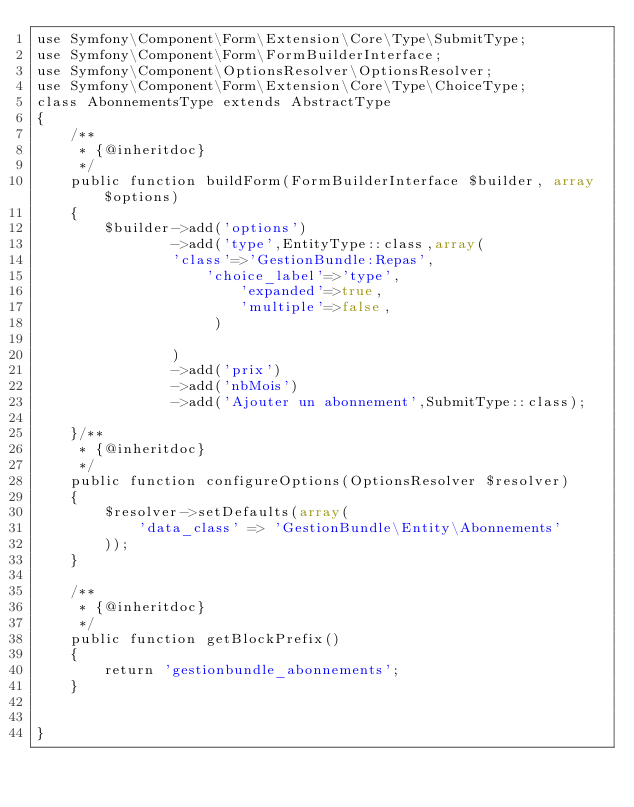<code> <loc_0><loc_0><loc_500><loc_500><_PHP_>use Symfony\Component\Form\Extension\Core\Type\SubmitType;
use Symfony\Component\Form\FormBuilderInterface;
use Symfony\Component\OptionsResolver\OptionsResolver;
use Symfony\Component\Form\Extension\Core\Type\ChoiceType;
class AbonnementsType extends AbstractType
{
    /**
     * {@inheritdoc}
     */
    public function buildForm(FormBuilderInterface $builder, array $options)
    {
        $builder->add('options')
                ->add('type',EntityType::class,array(
                'class'=>'GestionBundle:Repas',
                    'choice_label'=>'type',
                        'expanded'=>true,
                        'multiple'=>false,
                     )

                )
                ->add('prix')
                ->add('nbMois')
                ->add('Ajouter un abonnement',SubmitType::class);

    }/**
     * {@inheritdoc}
     */
    public function configureOptions(OptionsResolver $resolver)
    {
        $resolver->setDefaults(array(
            'data_class' => 'GestionBundle\Entity\Abonnements'
        ));
    }

    /**
     * {@inheritdoc}
     */
    public function getBlockPrefix()
    {
        return 'gestionbundle_abonnements';
    }


}
</code> 